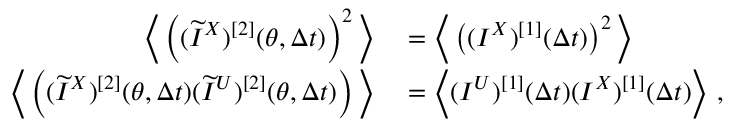Convert formula to latex. <formula><loc_0><loc_0><loc_500><loc_500>\begin{array} { r l } { \left \langle \left ( ( \widetilde { I } ^ { X } ) ^ { [ 2 ] } ( \theta , \Delta t ) \right ) ^ { 2 } \right \rangle } & = \left \langle \left ( ( I ^ { X } ) ^ { [ 1 ] } ( \Delta t ) \right ) ^ { 2 } \right \rangle } \\ { \left \langle \left ( ( \widetilde { I } ^ { X } ) ^ { [ 2 ] } ( \theta , \Delta t ) ( \widetilde { I } ^ { U } ) ^ { [ 2 ] } ( \theta , \Delta t ) \right ) \right \rangle } & = \left \langle ( I ^ { U } ) ^ { [ 1 ] } ( \Delta t ) ( I ^ { X } ) ^ { [ 1 ] } ( \Delta t ) \right \rangle , } \end{array}</formula> 